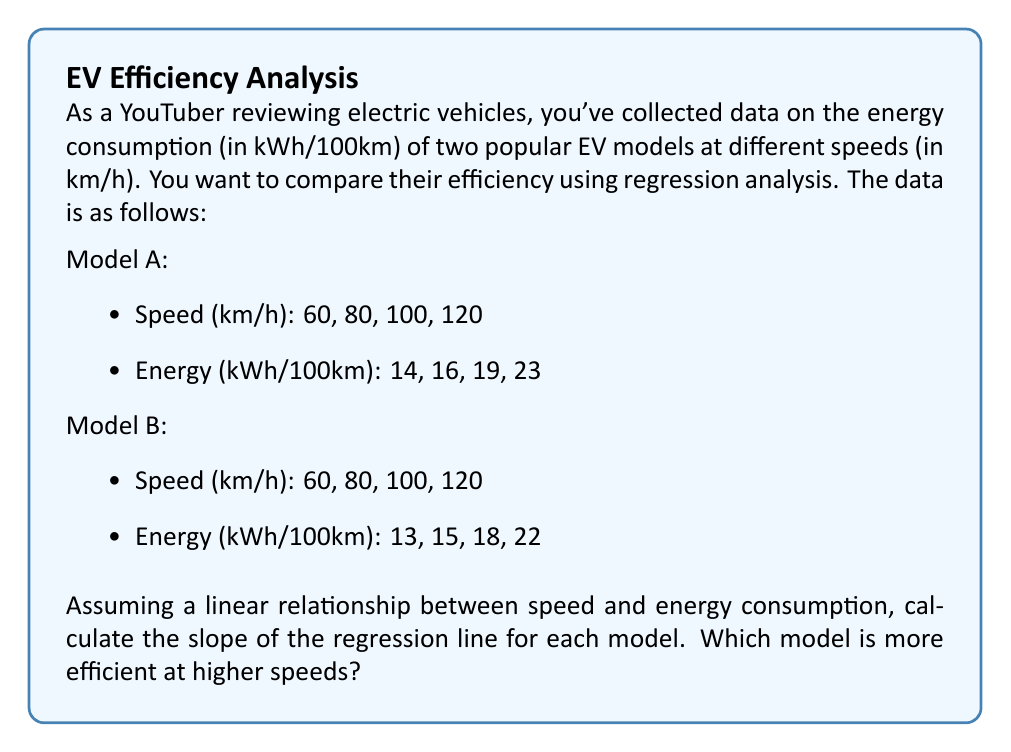Can you solve this math problem? To compare the efficiency of the two electric vehicle models, we'll use simple linear regression to find the relationship between speed and energy consumption for each model.

1. First, let's calculate the slope of the regression line for each model using the formula:

   $$b = \frac{n\sum xy - \sum x \sum y}{n\sum x^2 - (\sum x)^2}$$

   Where:
   $b$ is the slope
   $n$ is the number of data points
   $x$ is the speed
   $y$ is the energy consumption

2. For Model A:
   $n = 4$
   $\sum x = 60 + 80 + 100 + 120 = 360$
   $\sum y = 14 + 16 + 19 + 23 = 72$
   $\sum xy = (60 * 14) + (80 * 16) + (100 * 19) + (120 * 23) = 7,460$
   $\sum x^2 = 60^2 + 80^2 + 100^2 + 120^2 = 38,000$

   Plugging these values into the formula:

   $$b_A = \frac{4(7,460) - 360(72)}{4(38,000) - 360^2} = \frac{3,840}{24,400} = 0.15737$$

3. For Model B:
   $n = 4$
   $\sum x = 60 + 80 + 100 + 120 = 360$
   $\sum y = 13 + 15 + 18 + 22 = 68$
   $\sum xy = (60 * 13) + (80 * 15) + (100 * 18) + (120 * 22) = 7,040$
   $\sum x^2 = 60^2 + 80^2 + 100^2 + 120^2 = 38,000$

   Plugging these values into the formula:

   $$b_B = \frac{4(7,040) - 360(68)}{4(38,000) - 360^2} = \frac{3,600}{24,400} = 0.14754$$

4. Interpreting the results:
   - The slope represents the increase in energy consumption (kWh/100km) for each 1 km/h increase in speed.
   - Model A has a slope of 0.15737, while Model B has a slope of 0.14754.
   - A lower slope indicates better efficiency at higher speeds, as the energy consumption increases more slowly with speed.

Therefore, Model B is more efficient at higher speeds because it has a lower slope, meaning its energy consumption increases more slowly as speed increases.
Answer: Model B is more efficient at higher speeds. The slopes of the regression lines are:
Model A: 0.15737 kWh/100km per km/h
Model B: 0.14754 kWh/100km per km/h
Model B has a lower slope, indicating better efficiency at higher speeds. 